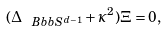Convert formula to latex. <formula><loc_0><loc_0><loc_500><loc_500>( \Delta _ { \ B b b { S } ^ { d - 1 } } + \kappa ^ { 2 } ) \Xi = 0 ,</formula> 